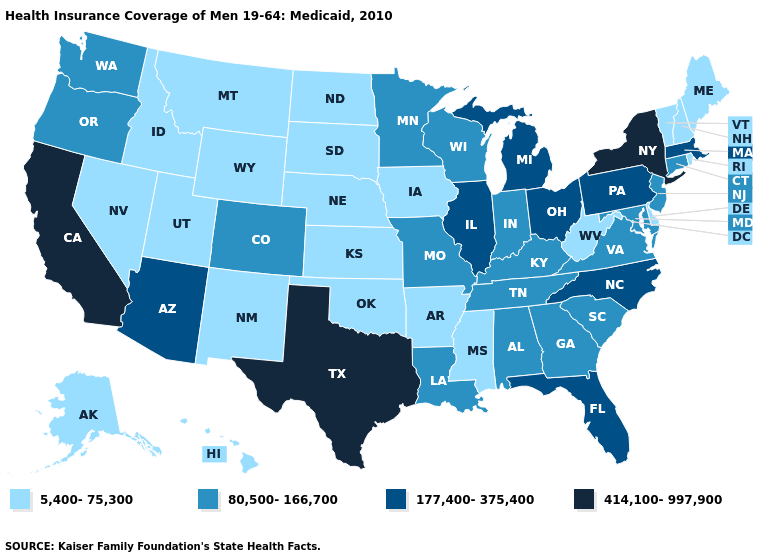Does Arkansas have the highest value in the USA?
Quick response, please. No. Does the map have missing data?
Write a very short answer. No. Does New York have a higher value than South Carolina?
Write a very short answer. Yes. Among the states that border Ohio , which have the lowest value?
Give a very brief answer. West Virginia. Does the first symbol in the legend represent the smallest category?
Keep it brief. Yes. What is the lowest value in the Northeast?
Write a very short answer. 5,400-75,300. Name the states that have a value in the range 5,400-75,300?
Write a very short answer. Alaska, Arkansas, Delaware, Hawaii, Idaho, Iowa, Kansas, Maine, Mississippi, Montana, Nebraska, Nevada, New Hampshire, New Mexico, North Dakota, Oklahoma, Rhode Island, South Dakota, Utah, Vermont, West Virginia, Wyoming. Does Indiana have the lowest value in the MidWest?
Answer briefly. No. Does the first symbol in the legend represent the smallest category?
Answer briefly. Yes. Among the states that border New York , which have the highest value?
Quick response, please. Massachusetts, Pennsylvania. What is the value of Ohio?
Short answer required. 177,400-375,400. Name the states that have a value in the range 5,400-75,300?
Short answer required. Alaska, Arkansas, Delaware, Hawaii, Idaho, Iowa, Kansas, Maine, Mississippi, Montana, Nebraska, Nevada, New Hampshire, New Mexico, North Dakota, Oklahoma, Rhode Island, South Dakota, Utah, Vermont, West Virginia, Wyoming. Name the states that have a value in the range 414,100-997,900?
Short answer required. California, New York, Texas. Name the states that have a value in the range 414,100-997,900?
Answer briefly. California, New York, Texas. 